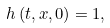<formula> <loc_0><loc_0><loc_500><loc_500>h \left ( t , x , 0 \right ) = 1 ,</formula> 